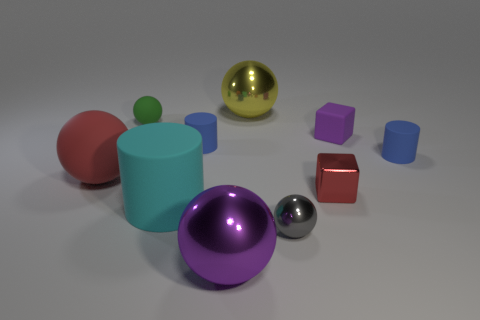Subtract all cyan rubber cylinders. How many cylinders are left? 2 Subtract all purple spheres. How many blue cylinders are left? 2 Subtract all yellow spheres. How many spheres are left? 4 Subtract 1 balls. How many balls are left? 4 Subtract all gray spheres. Subtract all cyan blocks. How many spheres are left? 4 Subtract all tiny cylinders. Subtract all cylinders. How many objects are left? 5 Add 9 small purple matte blocks. How many small purple matte blocks are left? 10 Add 1 small green matte balls. How many small green matte balls exist? 2 Subtract 1 gray balls. How many objects are left? 9 Subtract all cylinders. How many objects are left? 7 